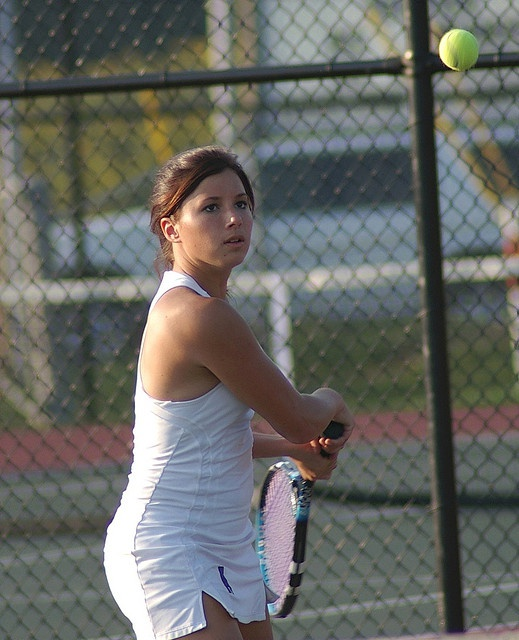Describe the objects in this image and their specific colors. I can see people in gray, white, and maroon tones, tennis racket in gray, darkgray, black, and pink tones, and sports ball in gray, olive, and khaki tones in this image. 